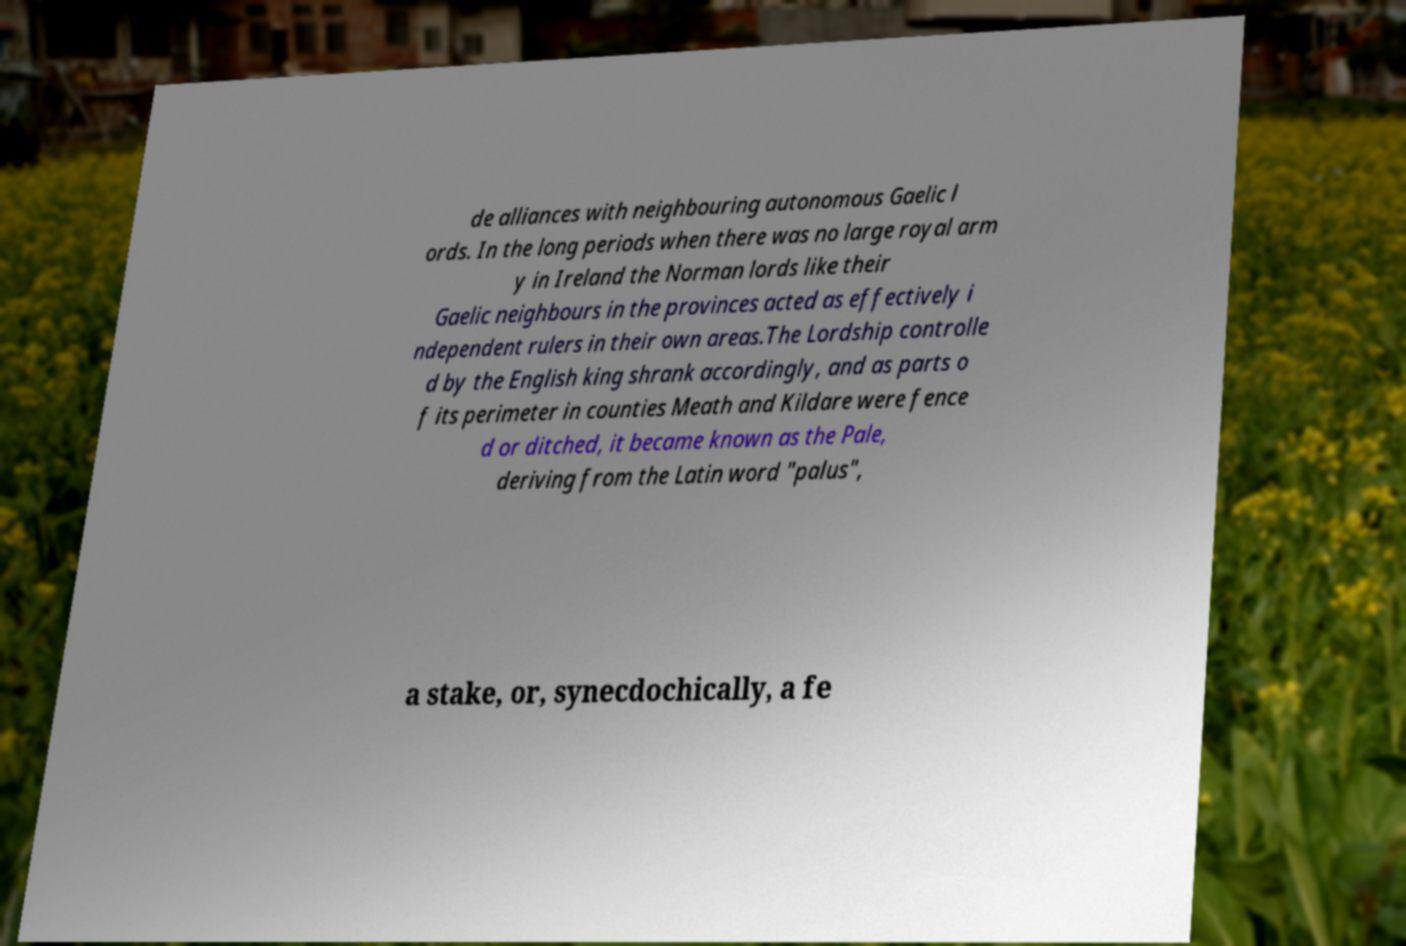I need the written content from this picture converted into text. Can you do that? de alliances with neighbouring autonomous Gaelic l ords. In the long periods when there was no large royal arm y in Ireland the Norman lords like their Gaelic neighbours in the provinces acted as effectively i ndependent rulers in their own areas.The Lordship controlle d by the English king shrank accordingly, and as parts o f its perimeter in counties Meath and Kildare were fence d or ditched, it became known as the Pale, deriving from the Latin word "palus", a stake, or, synecdochically, a fe 